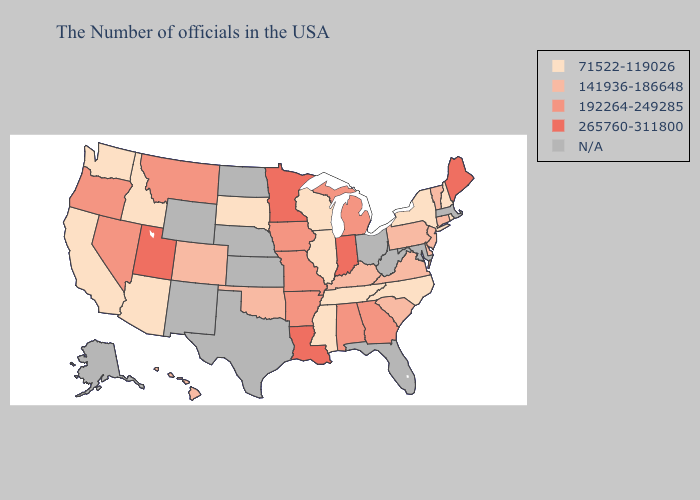Name the states that have a value in the range 71522-119026?
Short answer required. Rhode Island, New Hampshire, New York, North Carolina, Tennessee, Wisconsin, Illinois, Mississippi, South Dakota, Arizona, Idaho, California, Washington. Does Oregon have the lowest value in the West?
Quick response, please. No. Does Minnesota have the lowest value in the MidWest?
Be succinct. No. What is the value of New Hampshire?
Be succinct. 71522-119026. What is the value of Arizona?
Answer briefly. 71522-119026. Does the map have missing data?
Short answer required. Yes. What is the value of Maine?
Quick response, please. 265760-311800. Name the states that have a value in the range 265760-311800?
Concise answer only. Maine, Indiana, Louisiana, Minnesota, Utah. What is the lowest value in the USA?
Short answer required. 71522-119026. Name the states that have a value in the range 192264-249285?
Write a very short answer. Georgia, Michigan, Alabama, Missouri, Arkansas, Iowa, Montana, Nevada, Oregon. Does Arizona have the lowest value in the West?
Answer briefly. Yes. Name the states that have a value in the range N/A?
Concise answer only. Massachusetts, Maryland, West Virginia, Ohio, Florida, Kansas, Nebraska, Texas, North Dakota, Wyoming, New Mexico, Alaska. What is the highest value in the USA?
Quick response, please. 265760-311800. What is the lowest value in states that border Utah?
Concise answer only. 71522-119026. What is the value of Louisiana?
Quick response, please. 265760-311800. 